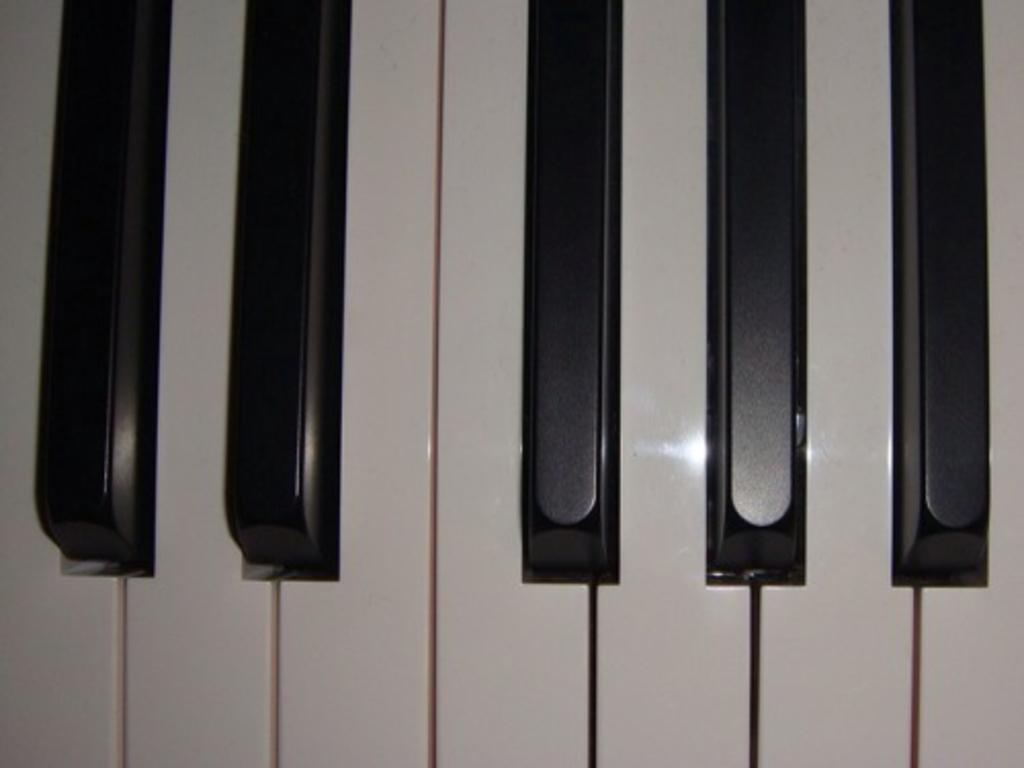Please provide a concise description of this image. There are keys of a piano,there are total five black keys and seven white keys. 